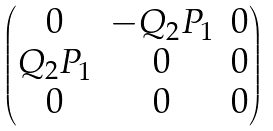Convert formula to latex. <formula><loc_0><loc_0><loc_500><loc_500>\begin{pmatrix} 0 & - Q _ { 2 } P _ { 1 } & 0 \\ Q _ { 2 } P _ { 1 } & 0 & 0 \\ 0 & 0 & 0 \end{pmatrix}</formula> 